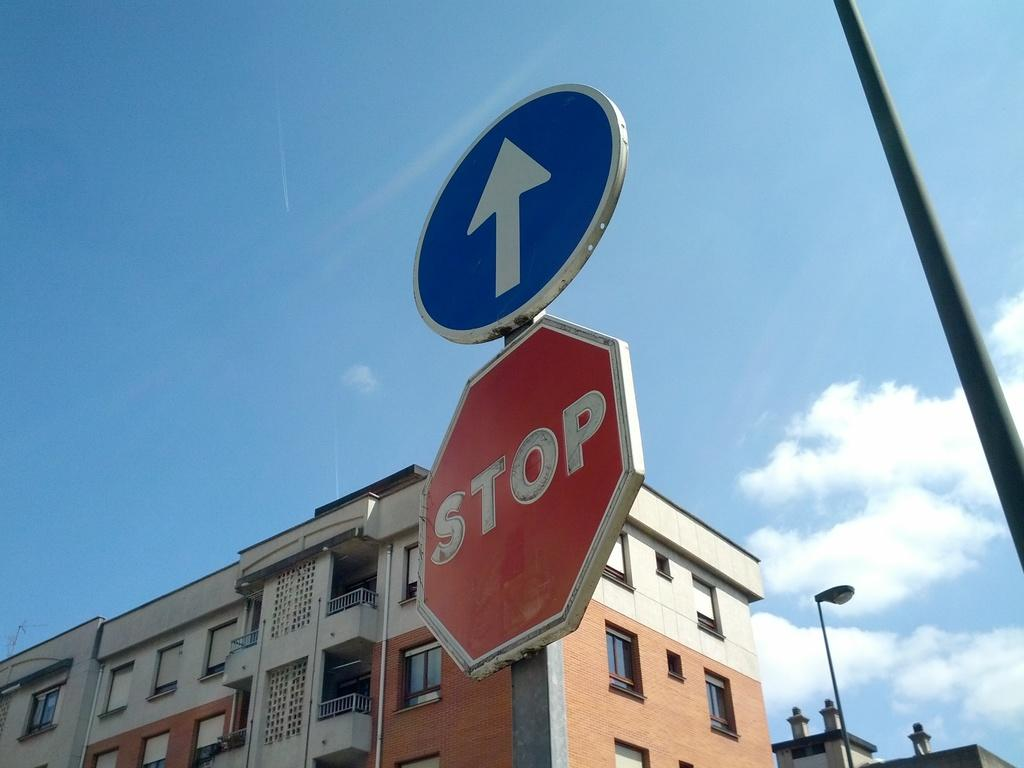<image>
Summarize the visual content of the image. A sign with an arrow is above a stop sign. 